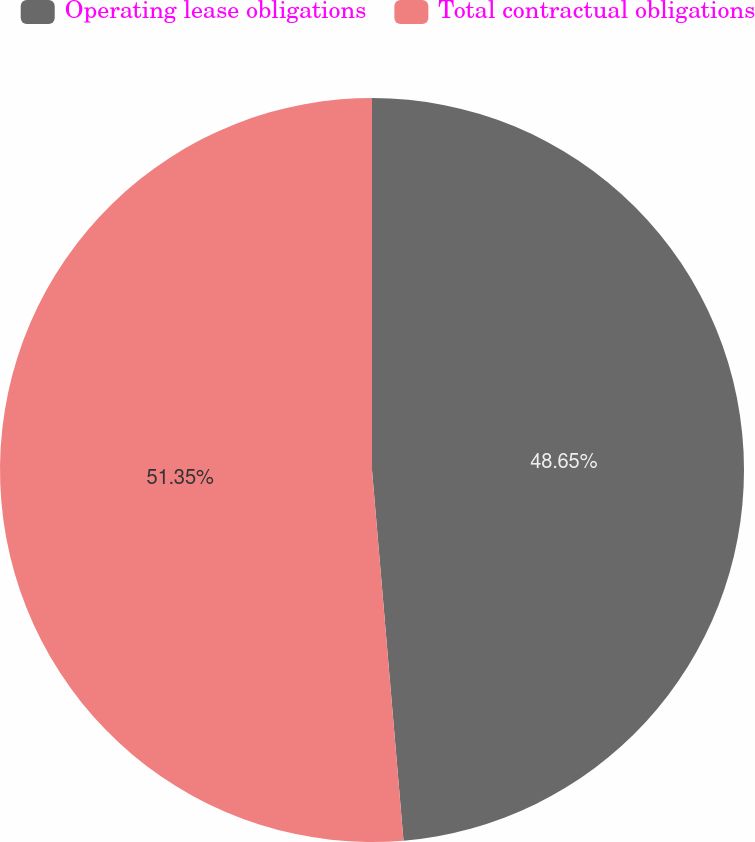<chart> <loc_0><loc_0><loc_500><loc_500><pie_chart><fcel>Operating lease obligations<fcel>Total contractual obligations<nl><fcel>48.65%<fcel>51.35%<nl></chart> 